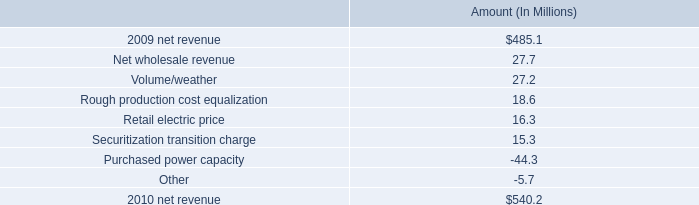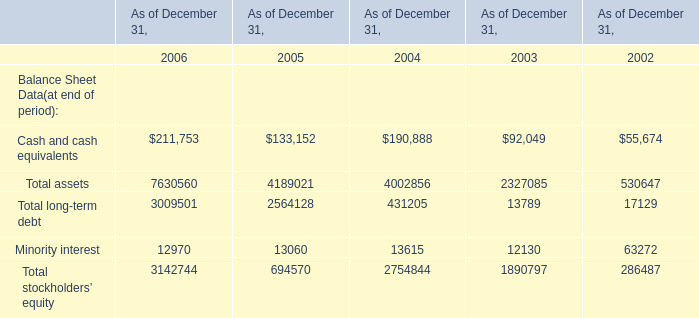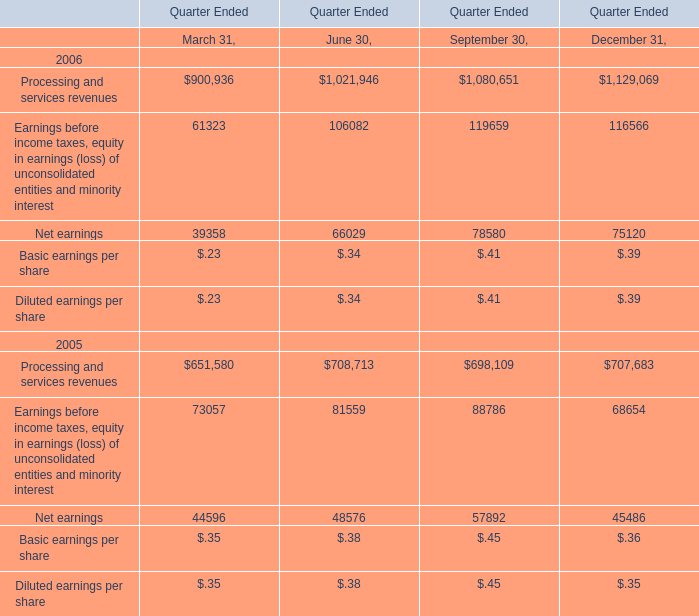What is the average value of Processing and services revenues in fo March 31, June 30, and September 30? (in million) 
Computations: (((900936 + 1021946) + 1080651) / 3)
Answer: 1001177.66667. 